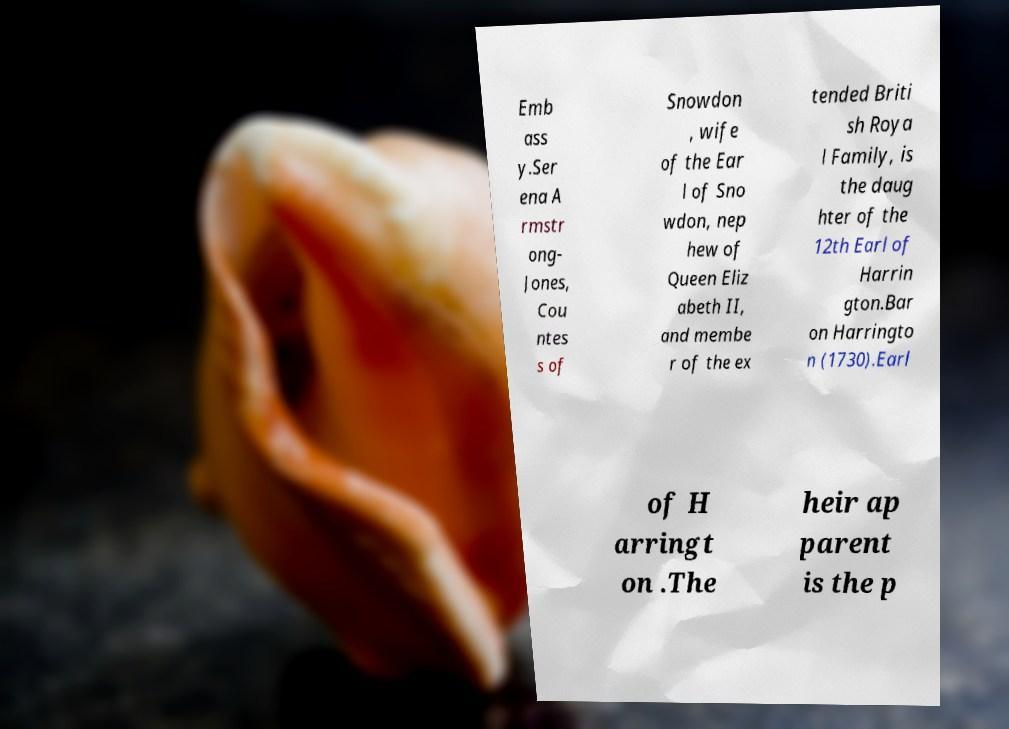Can you read and provide the text displayed in the image?This photo seems to have some interesting text. Can you extract and type it out for me? Emb ass y.Ser ena A rmstr ong- Jones, Cou ntes s of Snowdon , wife of the Ear l of Sno wdon, nep hew of Queen Eliz abeth II, and membe r of the ex tended Briti sh Roya l Family, is the daug hter of the 12th Earl of Harrin gton.Bar on Harringto n (1730).Earl of H arringt on .The heir ap parent is the p 